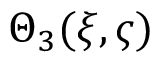<formula> <loc_0><loc_0><loc_500><loc_500>\Theta _ { 3 } ( \xi , \varsigma )</formula> 